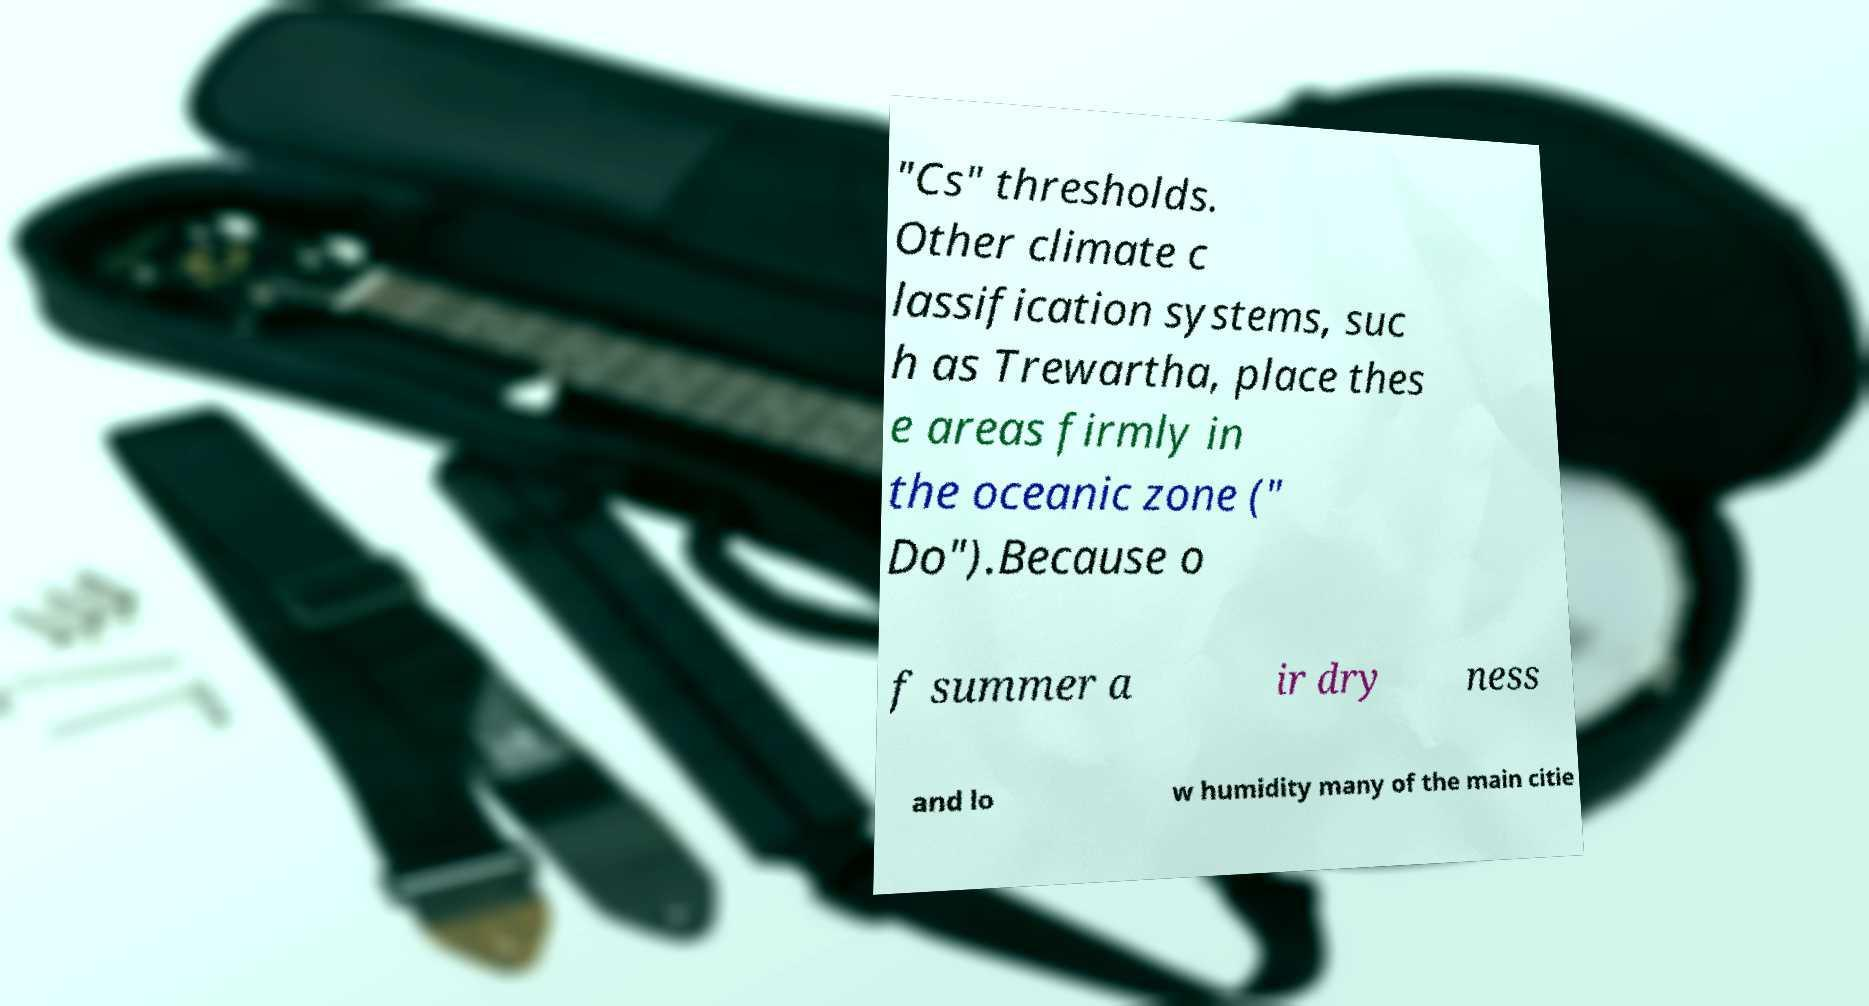Can you read and provide the text displayed in the image?This photo seems to have some interesting text. Can you extract and type it out for me? "Cs" thresholds. Other climate c lassification systems, suc h as Trewartha, place thes e areas firmly in the oceanic zone (" Do").Because o f summer a ir dry ness and lo w humidity many of the main citie 